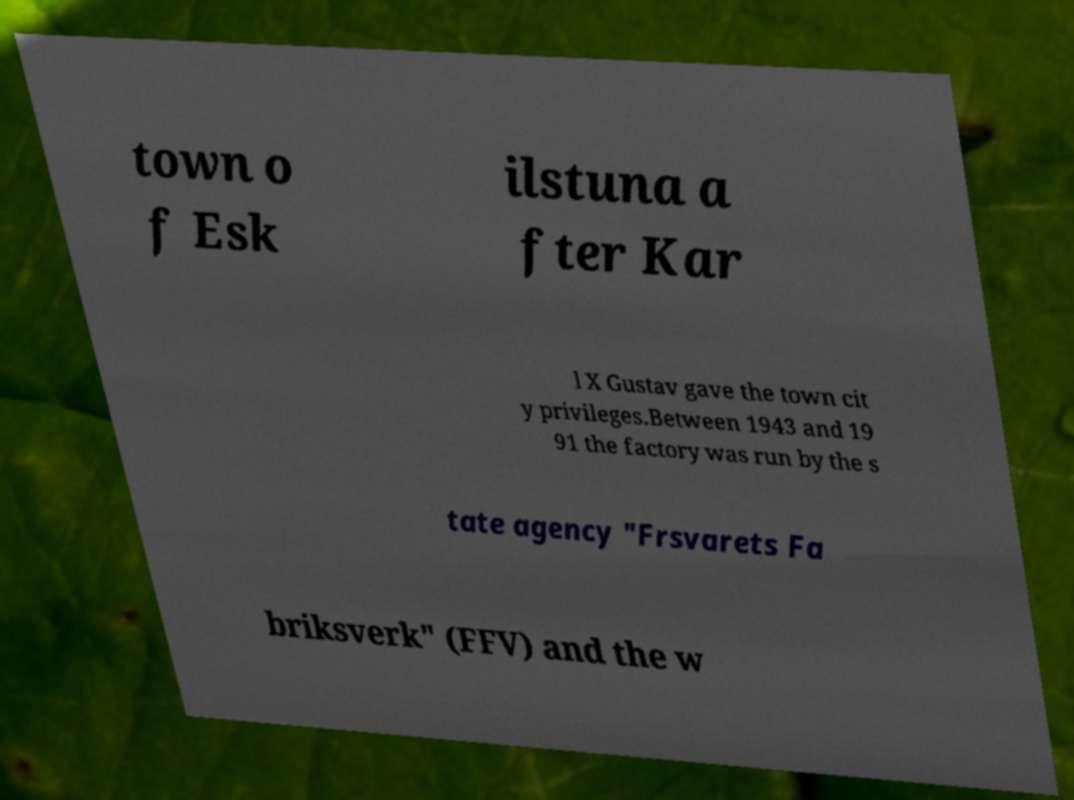Can you read and provide the text displayed in the image?This photo seems to have some interesting text. Can you extract and type it out for me? town o f Esk ilstuna a fter Kar l X Gustav gave the town cit y privileges.Between 1943 and 19 91 the factory was run by the s tate agency "Frsvarets Fa briksverk" (FFV) and the w 